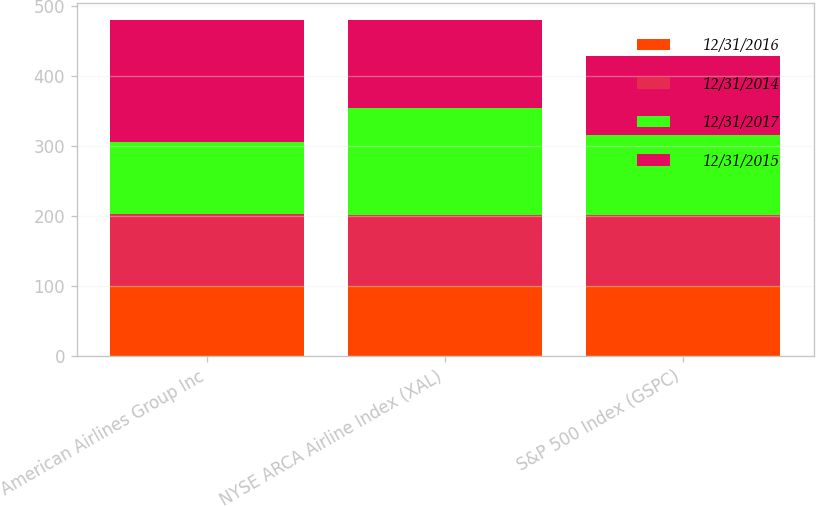Convert chart to OTSL. <chart><loc_0><loc_0><loc_500><loc_500><stacked_bar_chart><ecel><fcel>American Airlines Group Inc<fcel>NYSE ARCA Airline Index (XAL)<fcel>S&P 500 Index (GSPC)<nl><fcel>12/31/2016<fcel>100<fcel>100<fcel>100<nl><fcel>12/31/2014<fcel>103<fcel>102<fcel>102<nl><fcel>12/31/2017<fcel>103<fcel>152<fcel>114<nl><fcel>12/31/2015<fcel>175<fcel>127<fcel>113<nl></chart> 